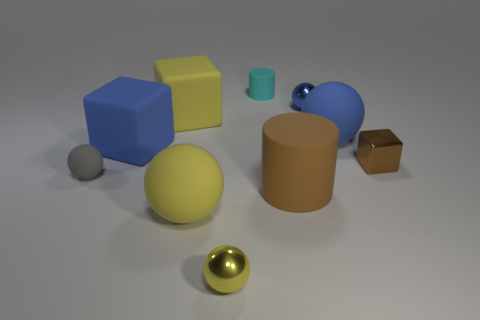Is the big cylinder the same color as the tiny matte cylinder?
Offer a terse response. No. What number of objects are either yellow objects or big matte objects to the right of the large brown rubber cylinder?
Offer a terse response. 4. There is a small shiny ball that is right of the cylinder that is in front of the large blue cube; how many tiny cyan cylinders are in front of it?
Keep it short and to the point. 0. There is a cylinder that is the same color as the shiny block; what material is it?
Provide a short and direct response. Rubber. How many small cylinders are there?
Provide a short and direct response. 1. There is a blue thing on the left side of the yellow cube; is its size the same as the large yellow ball?
Your response must be concise. Yes. What number of matte things are big brown spheres or yellow objects?
Your answer should be very brief. 2. There is a large yellow rubber cube that is to the left of the tiny metal cube; how many small cylinders are in front of it?
Give a very brief answer. 0. There is a tiny metallic object that is in front of the blue rubber ball and behind the yellow metallic sphere; what is its shape?
Your answer should be compact. Cube. There is a big block that is behind the large blue object that is left of the matte cylinder behind the small blue sphere; what is its material?
Provide a short and direct response. Rubber. 